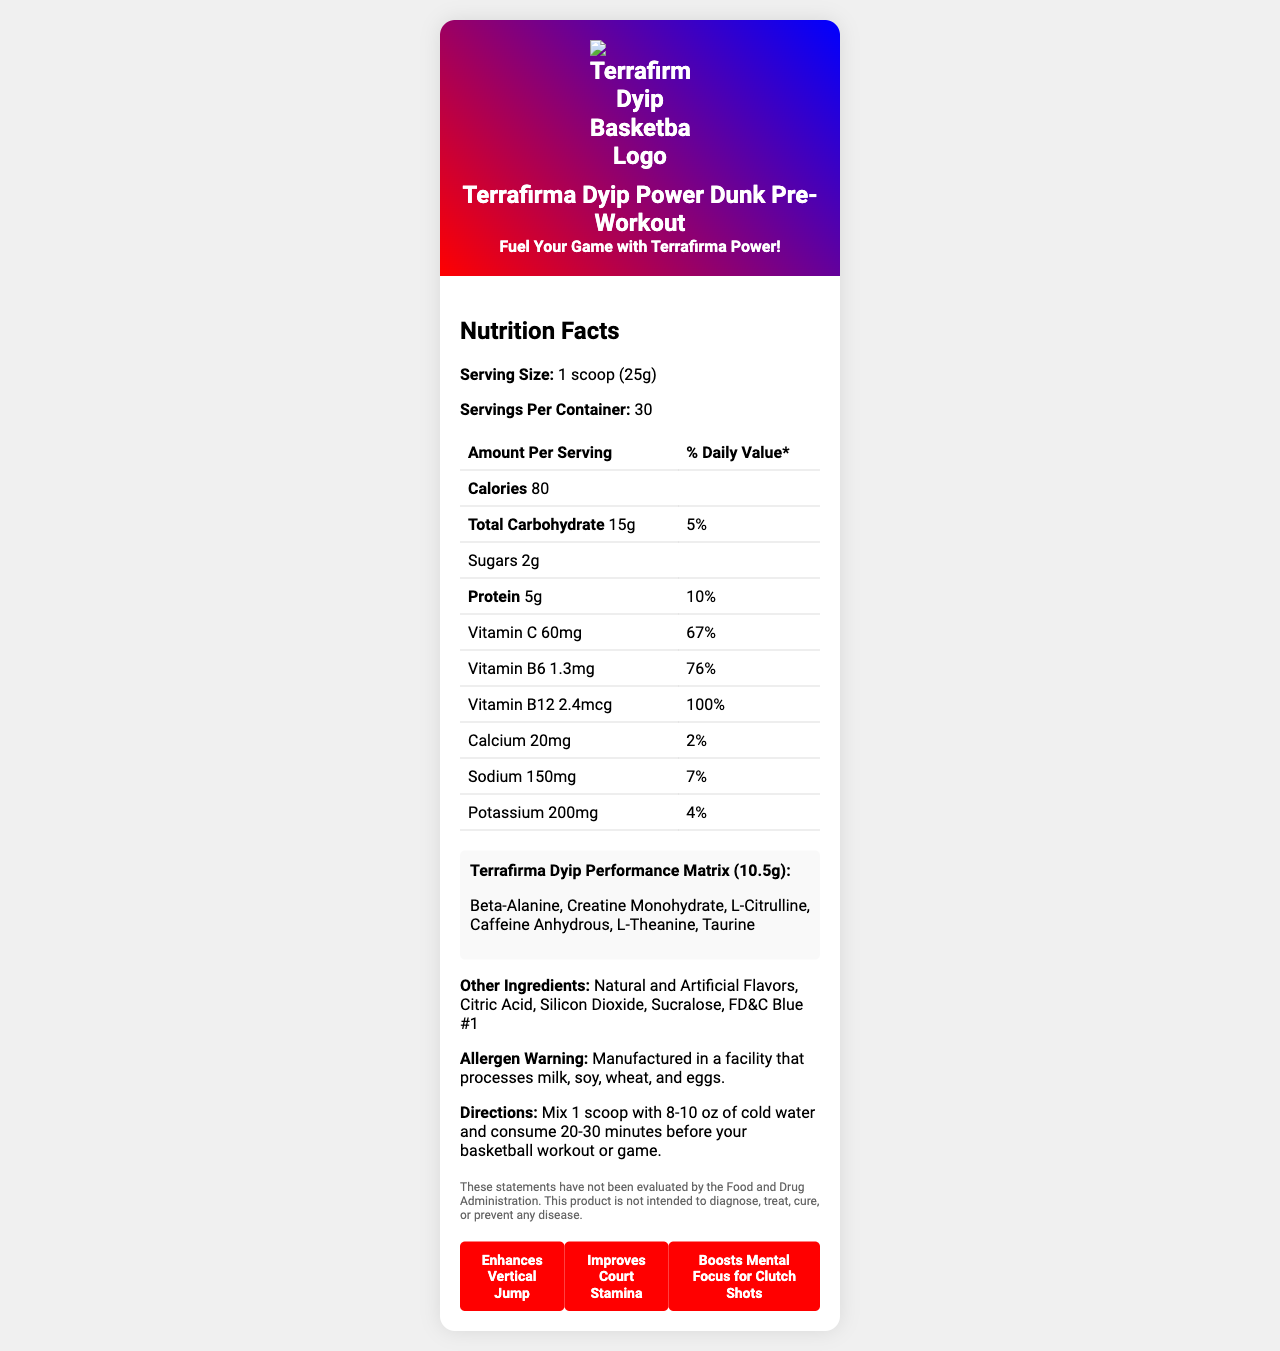what is the serving size? The serving size is clearly stated at the beginning of the nutrition facts section as "1 scoop (25g)".
Answer: 1 scoop (25g) how many calories are there per serving? The document lists the amount of calories per serving as "80".
Answer: 80 which vitamins are included in the Terrafirma Dyip Power Dunk Pre-Workout? The vitamins listed in the nutrition facts section are Vitamin C, Vitamin B6, and Vitamin B12.
Answer: Vitamin C, Vitamin B6, Vitamin B12 what is the recommended amount of water to mix with one scoop? The directions state to mix 1 scoop with 8-10 oz of cold water.
Answer: 8-10 oz of cold water how many grams of protein are there per serving? The amount of protein per serving is listed as "5g" in the nutrition facts table.
Answer: 5g how much sodium is in one serving? The table lists sodium content as "150mg" per serving.
Answer: 150mg what are the ingredients in the Terrafirma Dyip Performance Matrix? The proprietary blend called Terrafirma Dyip Performance Matrix includes these ingredients.
Answer: Beta-Alanine, Creatine Monohydrate, L-Citrulline, Caffeine Anhydrous, L-Theanine, Taurine which allergen warnings are associated with this product? The allergen warning states that the product is manufactured in a facility that processes milk, soy, wheat, and eggs.
Answer: Manufactured in a facility that processes milk, soy, wheat, and eggs. how many servings are there per container? The document states that there are 30 servings per container.
Answer: 30 what is the main idea of the document? The document provides comprehensive nutritional information about the pre-workout supplement including serving size, vitamin content, and ingredients. It also highlights the brand elements and basketball-specific claims.
Answer: A detailed nutrition facts label for Terrafirma Dyip Power Dunk Pre-Workout supplement designed for basketball enthusiasts. what is the percentage daily value of vitamin B12? A. 67% B. 76% C. 100% D. 10% The daily value percentage for vitamin B12 is listed in the nutrition facts as "100%".
Answer: C. 100% which statement is NOT a basketball-specific claim made by the product? A. Enhances Vertical Jump B. Improves Court Stamina C. Boosts Mental Focus for Clutch Shots D. Reduces Muscle Soreness The basketball-specific claims listed are "Enhances Vertical Jump," "Improves Court Stamina," and "Boosts Mental Focus for Clutch Shots." Reducing muscle soreness is not mentioned.
Answer: D. Reduces Muscle Soreness is the document providing sufficient information to determine the exact caffeine content? The proprietary blend lists "Caffeine Anhydrous" as one of the ingredients but does not specify the exact amount of caffeine per serving.
Answer: No does one serving of Terrafirma Dyip Power Dunk Pre-Workout exceed recommended daily values for any nutrient? One serving exceeds the recommended daily value for Vitamin B12 (100%) and Vitamin B6 (76%).
Answer: Yes what are the team colors featured in the branding elements? The team colors listed in the branding elements are Red, White, and Blue.
Answer: Red, White, Blue what is the allergen warning for Terrafirma Dyip Power Dunk Pre-Workout? A. Contains peanuts B. Contains lactose C. Manufactured in a facility that processes milk, soy, wheat, and eggs. The allergen warning states that the product is manufactured in a facility that processes milk, soy, wheat, and eggs.
Answer: C 